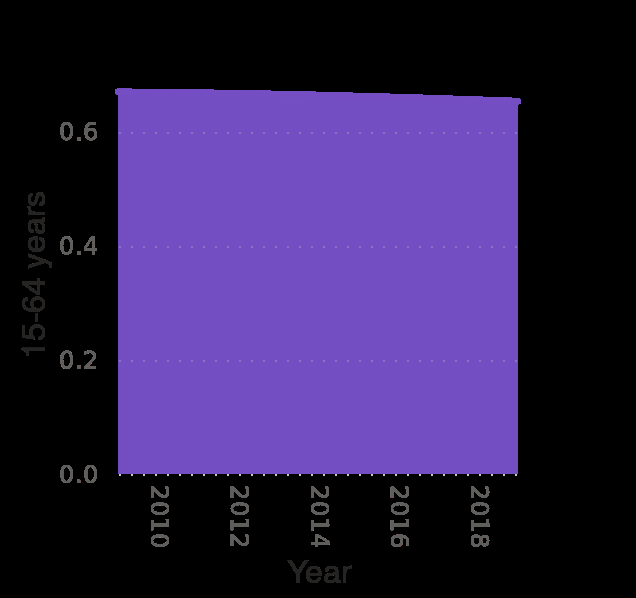<image>
Has the decrease in age distribution been consistent over the years? Yes, the decrease in age distribution has been consistent over the years. What type of graph is used to represent the age distribution in the United States? An area graph is used to represent the age distribution in the United States. What is the time period covered by the graph? The time period covered by the graph is from 2009 to 2019. Is the age distribution increasing or decreasing over the years? The age distribution is decreasing over the years. Describe the following image in detail Age distribution in the United States from 2009 to 2019 is a area graph. 15-64 years is measured along a scale with a minimum of 0.0 and a maximum of 0.6 along the y-axis. A linear scale from 2010 to 2018 can be found along the x-axis, labeled Year. Is the age distribution in the United States from 2009 to 2019 represented by a bar graph? No.Age distribution in the United States from 2009 to 2019 is a area graph. 15-64 years is measured along a scale with a minimum of 0.0 and a maximum of 0.6 along the y-axis. A linear scale from 2010 to 2018 can be found along the x-axis, labeled Year. Is a pie chart used to represent the age distribution in the United States? No.An area graph is used to represent the age distribution in the United States. 